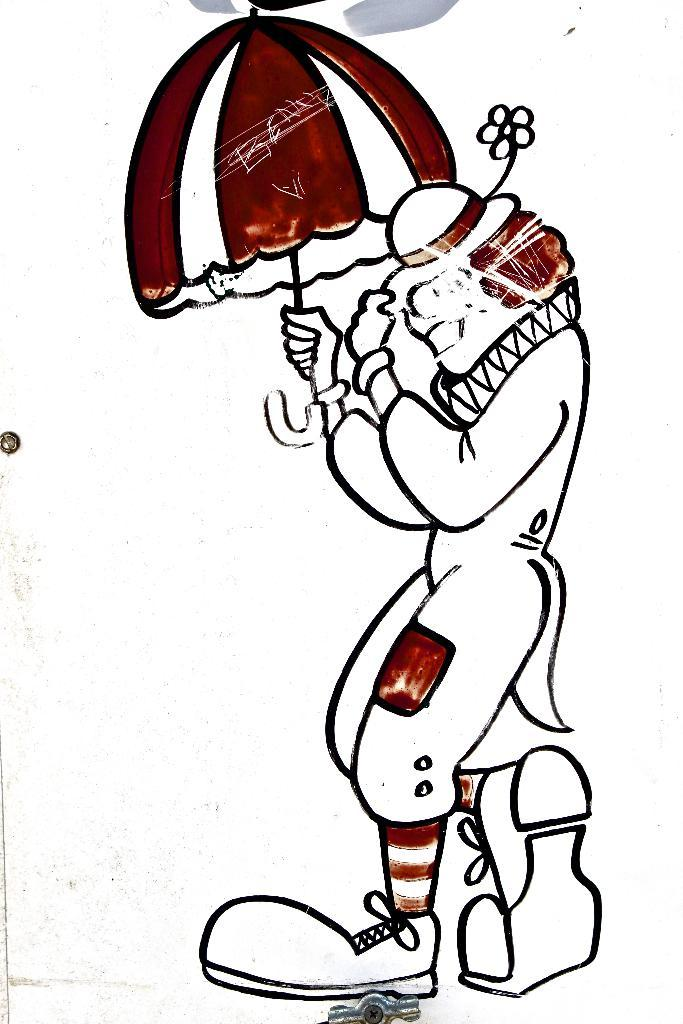What is the main subject of the image? There is a painting in the image. What is the painting depicting? The painting depicts a cartoon person. What is the cartoon person doing in the painting? The cartoon person is standing. What object is the cartoon person holding in the painting? The cartoon person is holding an umbrella. What type of toothpaste is the worm using in the image? There is no toothpaste or worm present in the image. 